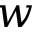Convert formula to latex. <formula><loc_0><loc_0><loc_500><loc_500>w</formula> 